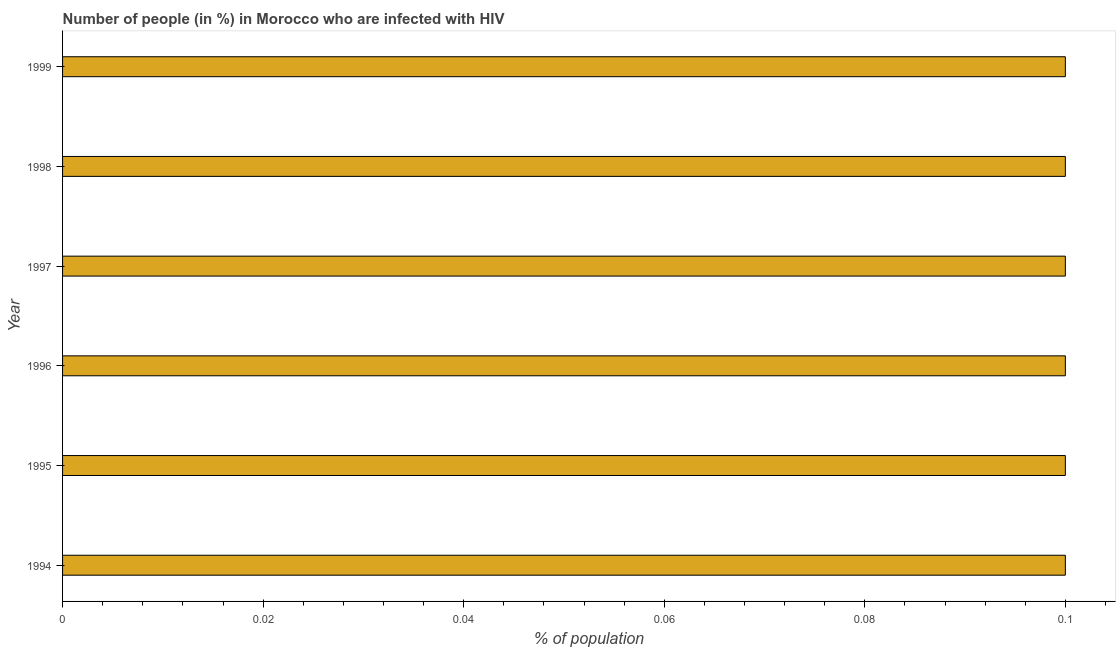Does the graph contain any zero values?
Give a very brief answer. No. Does the graph contain grids?
Provide a short and direct response. No. What is the title of the graph?
Give a very brief answer. Number of people (in %) in Morocco who are infected with HIV. What is the label or title of the X-axis?
Your response must be concise. % of population. Across all years, what is the maximum number of people infected with hiv?
Your answer should be very brief. 0.1. Across all years, what is the minimum number of people infected with hiv?
Your answer should be very brief. 0.1. In which year was the number of people infected with hiv maximum?
Offer a terse response. 1994. What is the sum of the number of people infected with hiv?
Offer a very short reply. 0.6. What is the median number of people infected with hiv?
Give a very brief answer. 0.1. In how many years, is the number of people infected with hiv greater than 0.1 %?
Make the answer very short. 0. What is the ratio of the number of people infected with hiv in 1996 to that in 1999?
Your answer should be very brief. 1. How many bars are there?
Your response must be concise. 6. How many years are there in the graph?
Your answer should be very brief. 6. What is the % of population of 1994?
Offer a very short reply. 0.1. What is the % of population of 1995?
Your response must be concise. 0.1. What is the % of population in 1996?
Ensure brevity in your answer.  0.1. What is the % of population in 1997?
Provide a succinct answer. 0.1. What is the % of population of 1998?
Offer a terse response. 0.1. What is the % of population of 1999?
Ensure brevity in your answer.  0.1. What is the difference between the % of population in 1994 and 1995?
Keep it short and to the point. 0. What is the difference between the % of population in 1994 and 1996?
Provide a short and direct response. 0. What is the difference between the % of population in 1994 and 1997?
Your response must be concise. 0. What is the difference between the % of population in 1995 and 1996?
Your answer should be compact. 0. What is the difference between the % of population in 1995 and 1998?
Make the answer very short. 0. What is the difference between the % of population in 1996 and 1998?
Give a very brief answer. 0. What is the difference between the % of population in 1996 and 1999?
Keep it short and to the point. 0. What is the difference between the % of population in 1997 and 1998?
Offer a very short reply. 0. What is the difference between the % of population in 1998 and 1999?
Provide a short and direct response. 0. What is the ratio of the % of population in 1994 to that in 1995?
Ensure brevity in your answer.  1. What is the ratio of the % of population in 1994 to that in 1996?
Keep it short and to the point. 1. What is the ratio of the % of population in 1995 to that in 1996?
Offer a very short reply. 1. What is the ratio of the % of population in 1995 to that in 1998?
Provide a short and direct response. 1. What is the ratio of the % of population in 1995 to that in 1999?
Provide a short and direct response. 1. What is the ratio of the % of population in 1996 to that in 1998?
Your response must be concise. 1. What is the ratio of the % of population in 1997 to that in 1998?
Provide a short and direct response. 1. What is the ratio of the % of population in 1998 to that in 1999?
Offer a very short reply. 1. 